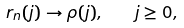Convert formula to latex. <formula><loc_0><loc_0><loc_500><loc_500>r _ { n } ( j ) \rightarrow \rho ( j ) , \quad j \geq 0 ,</formula> 